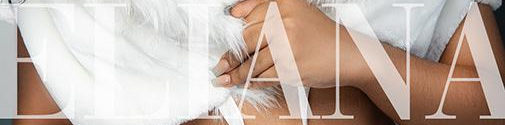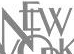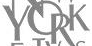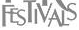What text is displayed in these images sequentially, separated by a semicolon? ELIANA; NEW; YORK; FESTIVALS 